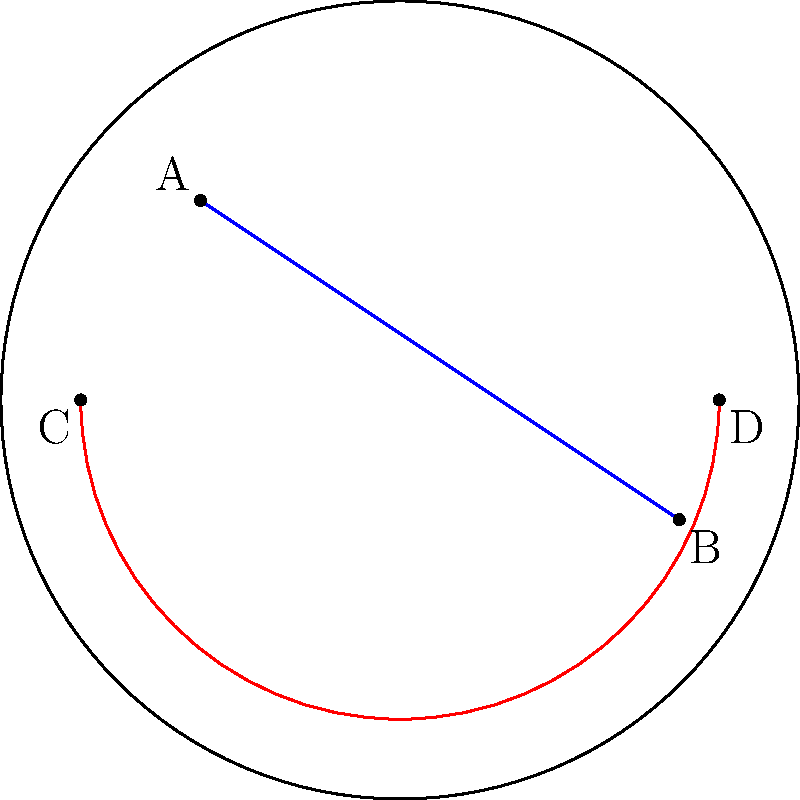In the Poincaré disk model of hyperbolic geometry shown above, which of the following statements is true about the blue line segment AB and the red arc CD?

a) They are parallel lines in hyperbolic space
b) They intersect at two points in hyperbolic space
c) They intersect at one point in hyperbolic space
d) They are perpendicular in hyperbolic space To answer this question, we need to understand the properties of the Poincaré disk model:

1. The Poincaré disk model represents the entire hyperbolic plane as the interior of a circular disk.

2. Straight lines in hyperbolic space are represented by either:
   a) Diameters of the disk
   b) Circular arcs that intersect the boundary circle at right angles

3. Parallel lines in hyperbolic space are represented by curves that do not intersect within the disk but meet at the boundary.

4. The blue line segment AB is part of a circular arc that intersects the boundary circle at right angles, representing a straight line in hyperbolic space.

5. The red arc CD is also a circular arc intersecting the boundary circle at right angles, representing another straight line in hyperbolic space.

6. Observing the diagram, we can see that the blue line segment AB and the red arc CD do not intersect within the disk but would meet if extended to the boundary.

7. This configuration in the Poincaré disk model represents parallel lines in hyperbolic space.

Therefore, the correct statement is that the blue line segment AB and the red arc CD are parallel lines in hyperbolic space.
Answer: a) They are parallel lines in hyperbolic space 